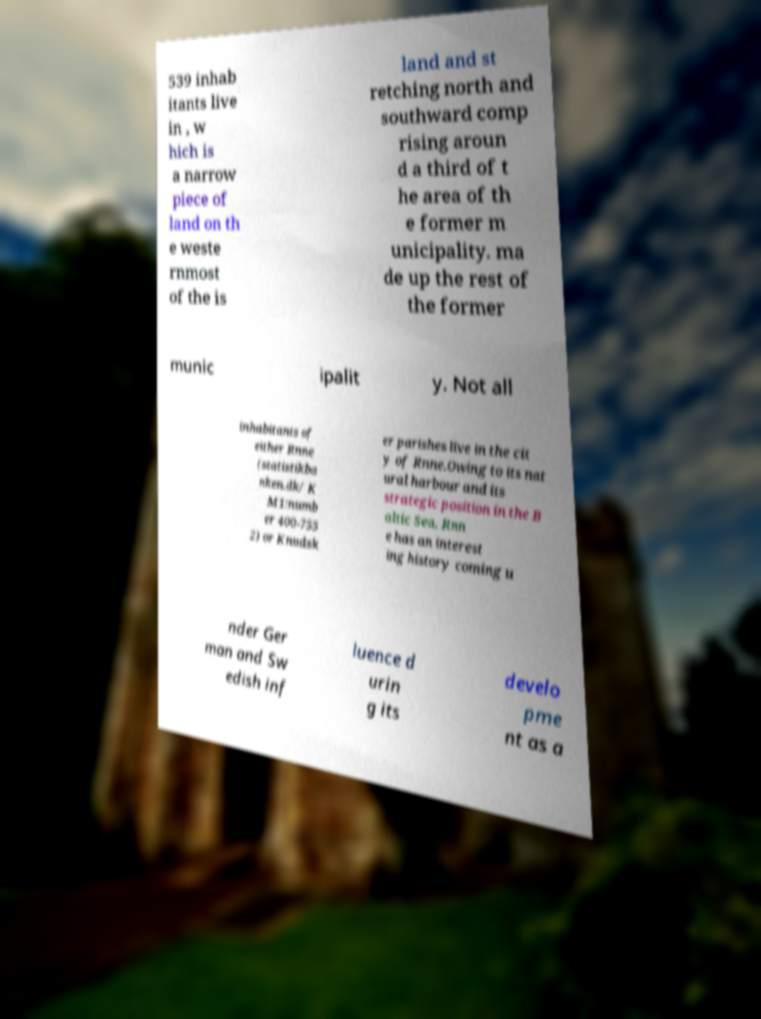Please identify and transcribe the text found in this image. 539 inhab itants live in , w hich is a narrow piece of land on th e weste rnmost of the is land and st retching north and southward comp rising aroun d a third of t he area of th e former m unicipality. ma de up the rest of the former munic ipalit y. Not all inhabitants of either Rnne (statistikba nken.dk/ K M1:numb er 400-755 2) or Knudsk er parishes live in the cit y of Rnne.Owing to its nat ural harbour and its strategic position in the B altic Sea, Rnn e has an interest ing history coming u nder Ger man and Sw edish inf luence d urin g its develo pme nt as a 